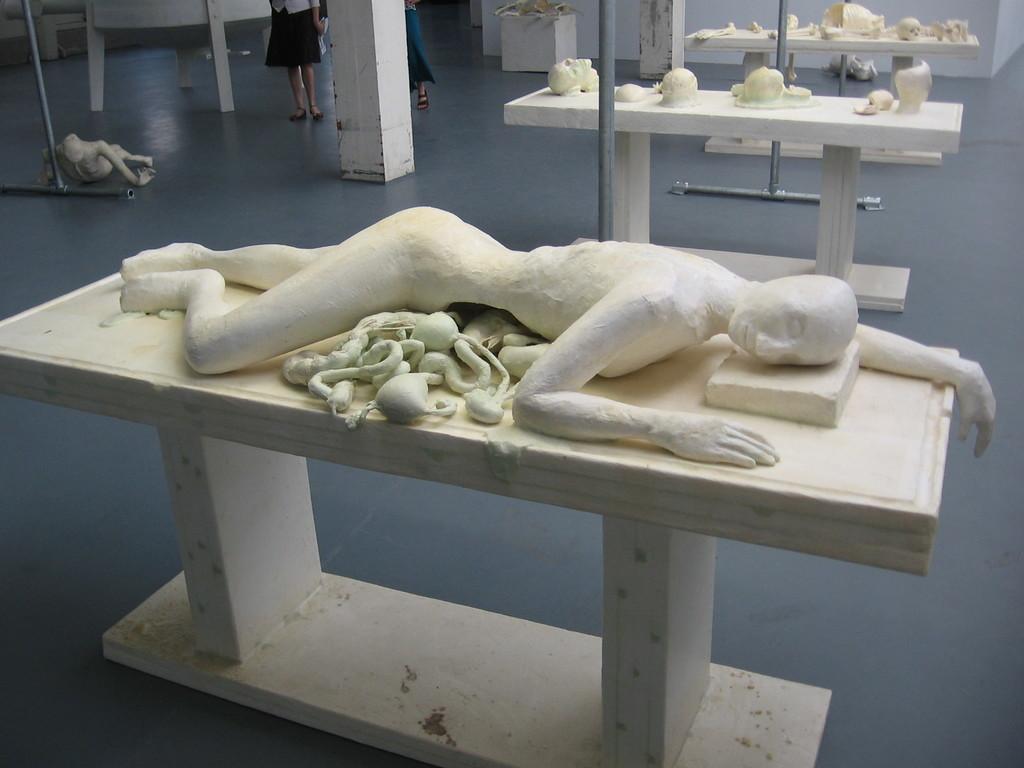Describe this image in one or two sentences. In this image a human statue is lying on the table having few objects on it. There are few tables having few sculptures on it. Left side there is a human statue. Few persons are standing on the floor. There are few metal stands on the floor. 